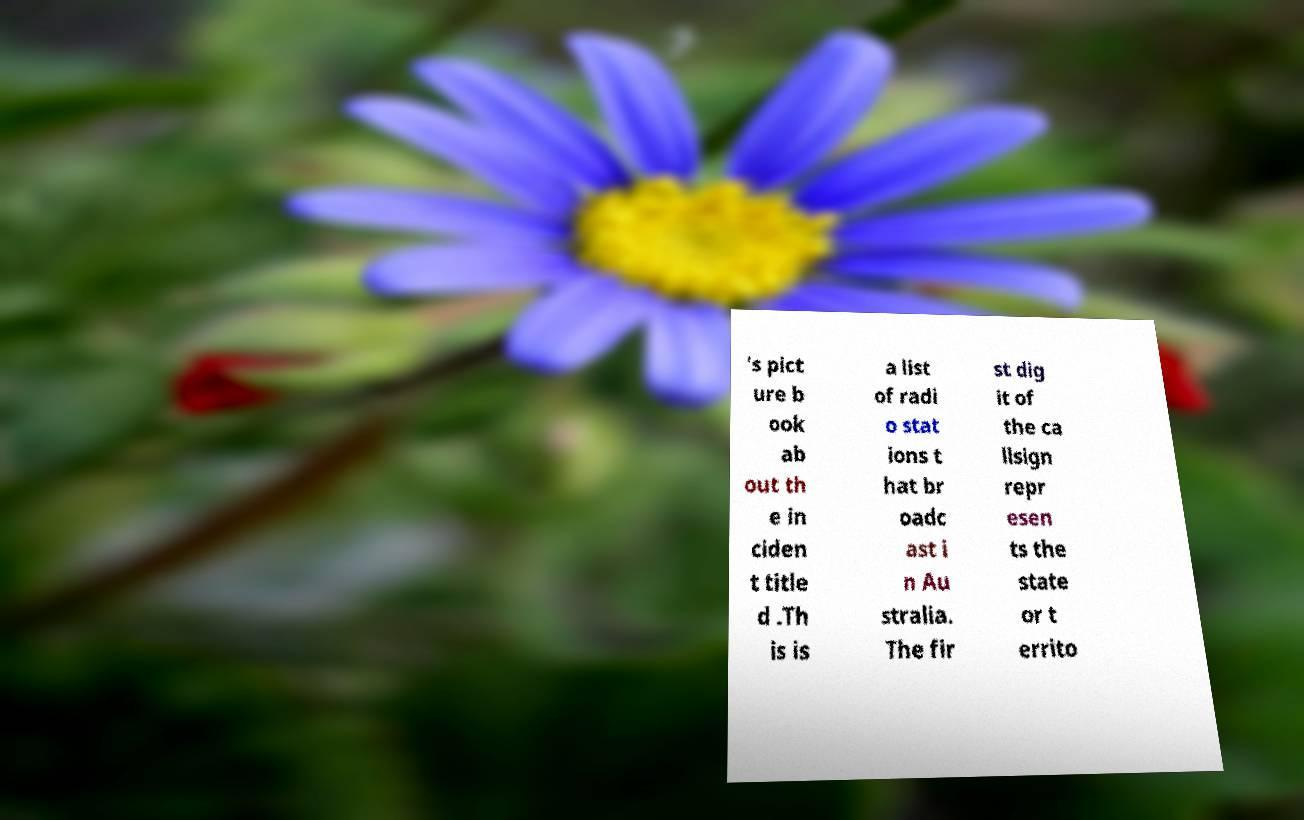There's text embedded in this image that I need extracted. Can you transcribe it verbatim? 's pict ure b ook ab out th e in ciden t title d .Th is is a list of radi o stat ions t hat br oadc ast i n Au stralia. The fir st dig it of the ca llsign repr esen ts the state or t errito 